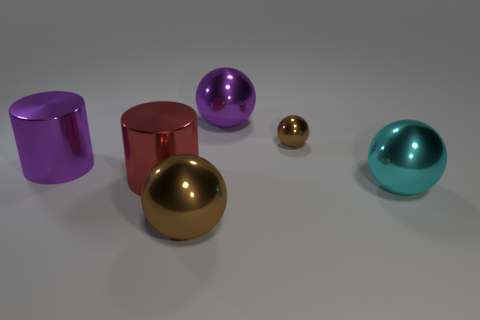Is there another big object of the same shape as the red thing?
Offer a very short reply. Yes. Does the brown thing in front of the cyan metal sphere have the same shape as the large red object to the right of the large purple shiny cylinder?
Offer a terse response. No. The big thing that is right of the large red cylinder and behind the red shiny cylinder has what shape?
Your answer should be compact. Sphere. Is there a brown thing of the same size as the purple sphere?
Offer a terse response. Yes. There is a tiny object; does it have the same color as the big object in front of the large cyan object?
Make the answer very short. Yes. The big shiny ball in front of the cyan thing is what color?
Offer a terse response. Brown. What number of big spheres are the same color as the small ball?
Provide a short and direct response. 1. What number of big things are in front of the small brown sphere and on the left side of the small shiny sphere?
Make the answer very short. 3. There is a cyan metal object that is the same size as the red cylinder; what shape is it?
Give a very brief answer. Sphere. What size is the cyan metallic ball?
Make the answer very short. Large. 